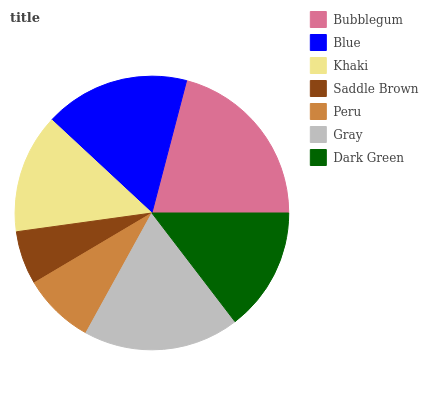Is Saddle Brown the minimum?
Answer yes or no. Yes. Is Bubblegum the maximum?
Answer yes or no. Yes. Is Blue the minimum?
Answer yes or no. No. Is Blue the maximum?
Answer yes or no. No. Is Bubblegum greater than Blue?
Answer yes or no. Yes. Is Blue less than Bubblegum?
Answer yes or no. Yes. Is Blue greater than Bubblegum?
Answer yes or no. No. Is Bubblegum less than Blue?
Answer yes or no. No. Is Dark Green the high median?
Answer yes or no. Yes. Is Dark Green the low median?
Answer yes or no. Yes. Is Bubblegum the high median?
Answer yes or no. No. Is Bubblegum the low median?
Answer yes or no. No. 